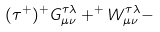Convert formula to latex. <formula><loc_0><loc_0><loc_500><loc_500>( \tau ^ { + } ) ^ { + } G _ { \mu \nu } ^ { \tau \lambda } + ^ { + } W _ { \mu \nu } ^ { \tau \lambda } -</formula> 